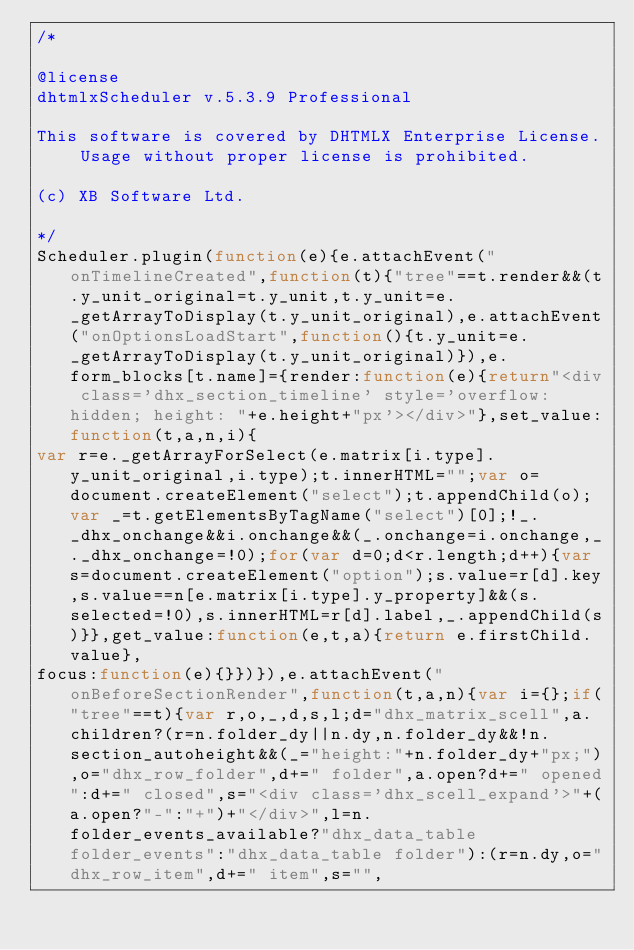<code> <loc_0><loc_0><loc_500><loc_500><_JavaScript_>/*

@license
dhtmlxScheduler v.5.3.9 Professional

This software is covered by DHTMLX Enterprise License. Usage without proper license is prohibited.

(c) XB Software Ltd.

*/
Scheduler.plugin(function(e){e.attachEvent("onTimelineCreated",function(t){"tree"==t.render&&(t.y_unit_original=t.y_unit,t.y_unit=e._getArrayToDisplay(t.y_unit_original),e.attachEvent("onOptionsLoadStart",function(){t.y_unit=e._getArrayToDisplay(t.y_unit_original)}),e.form_blocks[t.name]={render:function(e){return"<div class='dhx_section_timeline' style='overflow: hidden; height: "+e.height+"px'></div>"},set_value:function(t,a,n,i){
var r=e._getArrayForSelect(e.matrix[i.type].y_unit_original,i.type);t.innerHTML="";var o=document.createElement("select");t.appendChild(o);var _=t.getElementsByTagName("select")[0];!_._dhx_onchange&&i.onchange&&(_.onchange=i.onchange,_._dhx_onchange=!0);for(var d=0;d<r.length;d++){var s=document.createElement("option");s.value=r[d].key,s.value==n[e.matrix[i.type].y_property]&&(s.selected=!0),s.innerHTML=r[d].label,_.appendChild(s)}},get_value:function(e,t,a){return e.firstChild.value},
focus:function(e){}})}),e.attachEvent("onBeforeSectionRender",function(t,a,n){var i={};if("tree"==t){var r,o,_,d,s,l;d="dhx_matrix_scell",a.children?(r=n.folder_dy||n.dy,n.folder_dy&&!n.section_autoheight&&(_="height:"+n.folder_dy+"px;"),o="dhx_row_folder",d+=" folder",a.open?d+=" opened":d+=" closed",s="<div class='dhx_scell_expand'>"+(a.open?"-":"+")+"</div>",l=n.folder_events_available?"dhx_data_table folder_events":"dhx_data_table folder"):(r=n.dy,o="dhx_row_item",d+=" item",s="",</code> 